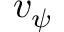<formula> <loc_0><loc_0><loc_500><loc_500>v _ { \psi }</formula> 